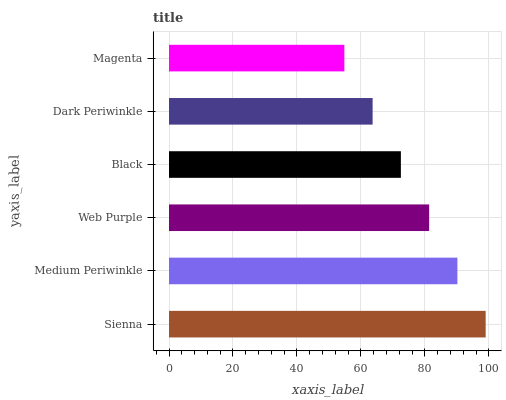Is Magenta the minimum?
Answer yes or no. Yes. Is Sienna the maximum?
Answer yes or no. Yes. Is Medium Periwinkle the minimum?
Answer yes or no. No. Is Medium Periwinkle the maximum?
Answer yes or no. No. Is Sienna greater than Medium Periwinkle?
Answer yes or no. Yes. Is Medium Periwinkle less than Sienna?
Answer yes or no. Yes. Is Medium Periwinkle greater than Sienna?
Answer yes or no. No. Is Sienna less than Medium Periwinkle?
Answer yes or no. No. Is Web Purple the high median?
Answer yes or no. Yes. Is Black the low median?
Answer yes or no. Yes. Is Sienna the high median?
Answer yes or no. No. Is Web Purple the low median?
Answer yes or no. No. 